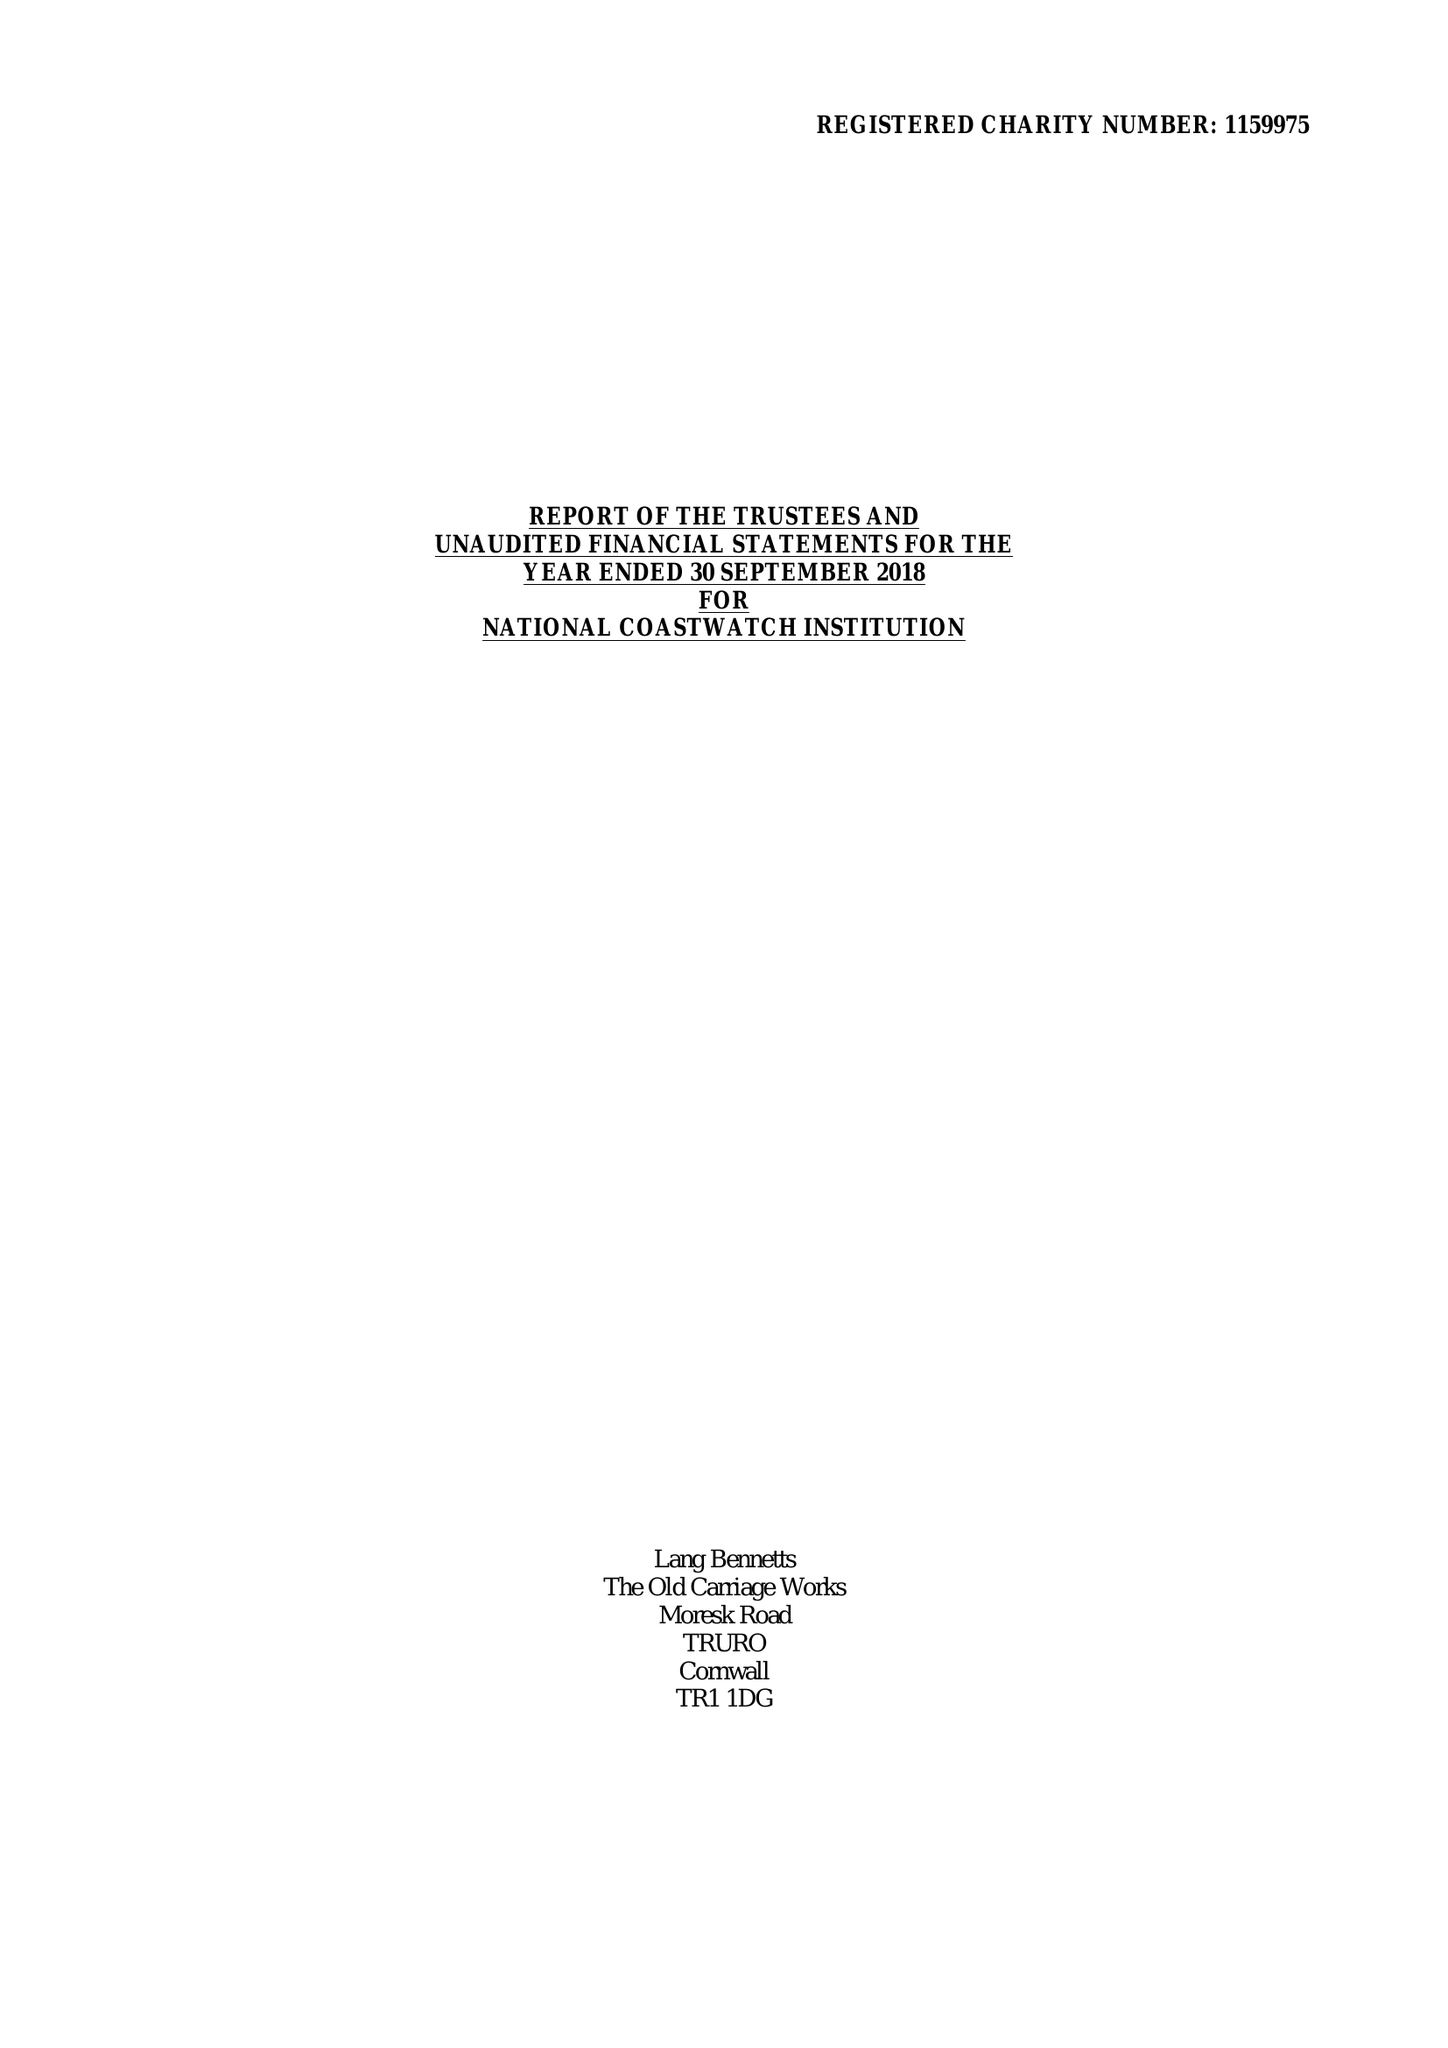What is the value for the charity_name?
Answer the question using a single word or phrase. National Coastwatch Institution 